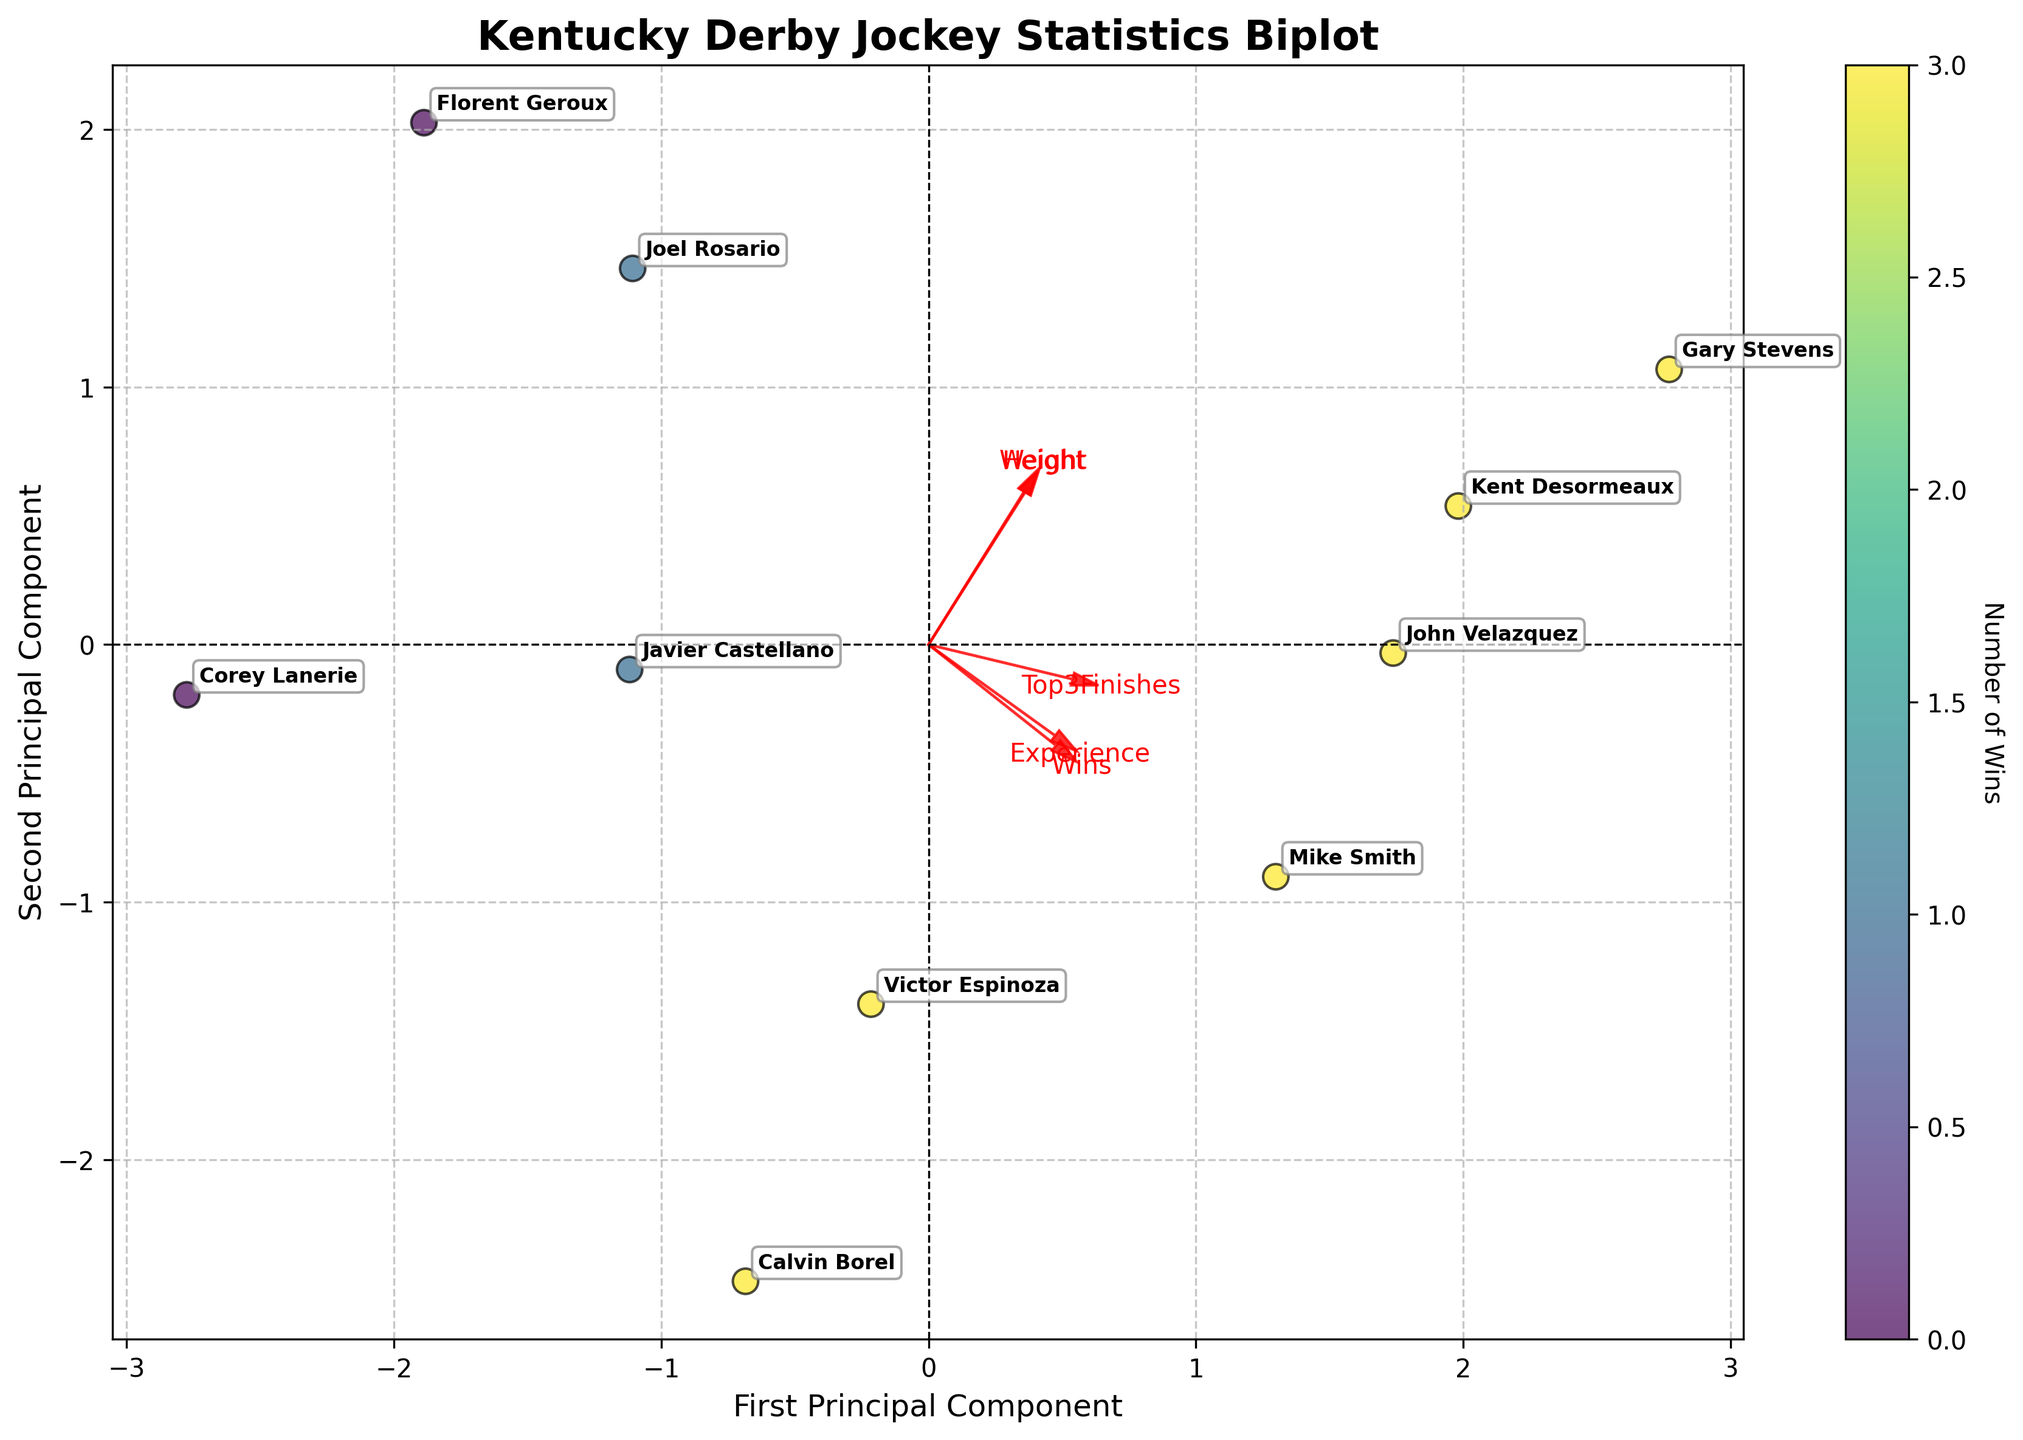What is the title of the biplot? The title is located at the top of the biplot and it is usually in a larger, bold font.
Answer: Kentucky Derby Jockey Statistics Biplot Which jockey has the highest number of wins? The color of the data points indicates the number of wins. By finding the darkest data point, you can identify the jockey with the most wins.
Answer: Mike Smith, John Velazquez, Victor Espinoza, Calvin Borel, Kent Desormeaux, and Gary Stevens all have 3 wins Which feature vectors are plotted on the first and second components of the PCA? The biplot shows arrows starting from the origin representing different features. Examine the arrows and their labels to determine the feature vectors plotted.
Answer: Weight, Height, Experience, Wins, Top3Finishes How is the number of wins represented in the biplot? The number of wins is indicated by the color of the data points. The color gradient (mapped to the color bar) represents the varying number of wins.
Answer: By color Which jockey has the lowest experience but still has wins? Jockeys are annotated by their names, and the arrows' directions indicate the relative amount of each feature. Find the jockey with the lowest experience arrow direction who has a colored dot indicating non-zero wins.
Answer: Joel Rosario What principal component explains the most variance? The variance explained by each principal component is usually indicated either in the axis labels or within the PCA analysis section. The principal component with the larger explained variance typically corresponds to the x-axis.
Answer: First Principal Component Is there any jockey who has zero wins? If yes, who? Identify the color gradient that corresponds to zero wins from the color bar and find the dots that match this color.
Answer: Corey Lanerie, Florent Geroux Which features are most strongly correlated with each other according to the biplot? Features that have arrows pointing in the same or opposite directions are strongly positively or negatively correlated, respectively.
Answer: Weight and Height are positively correlated with Wins and Top3Finishes Based on the biplot, does experience correlate more with height or with weight? Compare the angles between the experience arrow and those of height and weight. A smaller angle indicates a stronger correlation.
Answer: Height Which jockeys are closest to the origin of the plot, and what might that imply? Look for dots that are nearest to the (0,0) point on the plot. The relative closeness to the origin can imply average values across the majority of features.
Answer: Florent Geroux and Corey Lanerie 